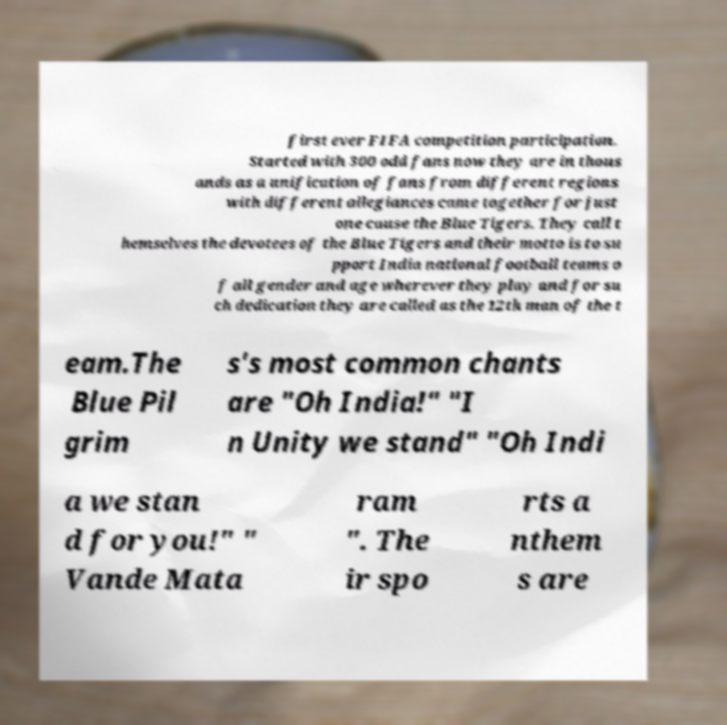Please read and relay the text visible in this image. What does it say? first ever FIFA competition participation. Started with 300 odd fans now they are in thous ands as a unification of fans from different regions with different allegiances came together for just one cause the Blue Tigers. They call t hemselves the devotees of the Blue Tigers and their motto is to su pport India national football teams o f all gender and age wherever they play and for su ch dedication they are called as the 12th man of the t eam.The Blue Pil grim s's most common chants are "Oh India!" "I n Unity we stand" "Oh Indi a we stan d for you!" " Vande Mata ram ". The ir spo rts a nthem s are 